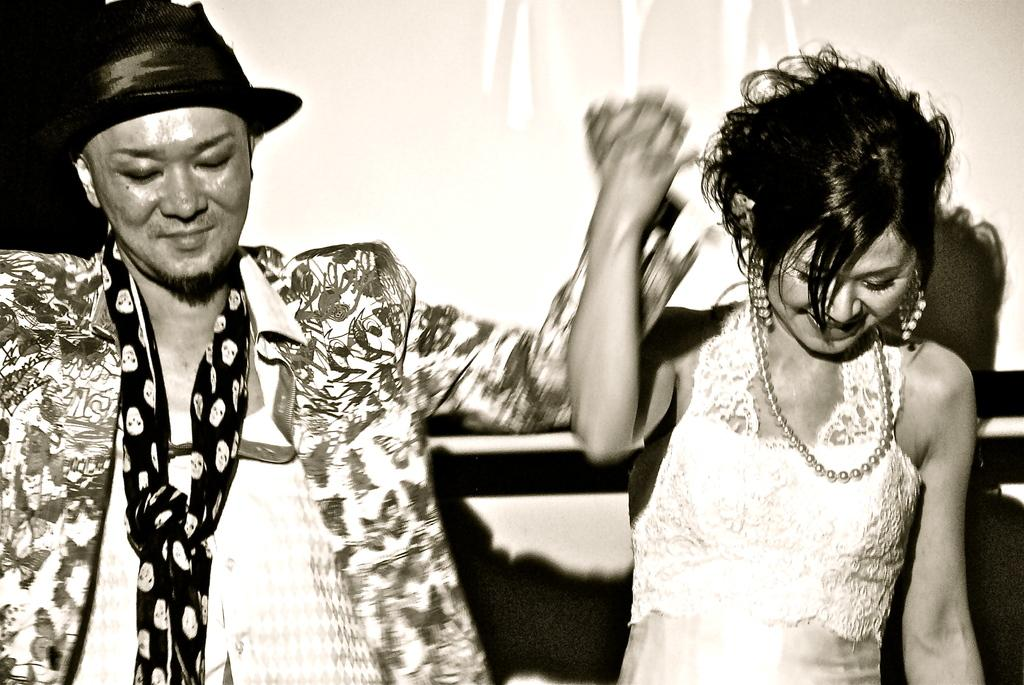What is the color scheme of the image? The image is black and white. What are the man and woman doing in the middle of the image? The man and woman are dancing in the middle of the image. How do the man and woman appear to feel while dancing? The man and woman have smiling faces, which suggests they are enjoying themselves. What can be seen in the background of the image? There is a screen on the wall in the background of the image. What type of oil is being used by the man and woman while dancing in the image? There is no oil present in the image; it is a black and white photograph of a man and woman dancing. How many chickens are visible on the screen in the background of the image? There are no chickens visible on the screen in the background of the image; it is a screen on the wall, and its content is not described in the provided facts. 